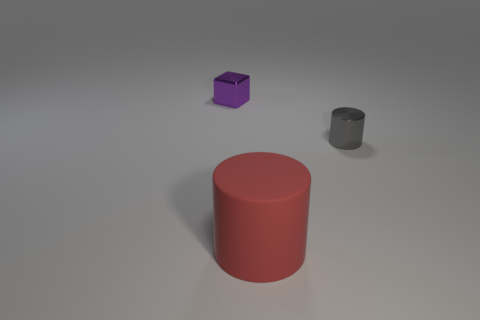Is there any other thing that has the same material as the red object?
Offer a very short reply. No. What number of things have the same material as the tiny gray cylinder?
Provide a succinct answer. 1. Is the number of tiny purple rubber objects less than the number of tiny gray metal things?
Provide a short and direct response. Yes. Do the small object that is on the left side of the small metal cylinder and the red object have the same material?
Your answer should be compact. No. How many cubes are tiny gray objects or big red rubber things?
Provide a succinct answer. 0. The object that is both on the left side of the tiny gray thing and on the right side of the small purple shiny cube has what shape?
Provide a succinct answer. Cylinder. The small object that is on the right side of the tiny metallic thing on the left side of the cylinder behind the rubber cylinder is what color?
Your response must be concise. Gray. Is the number of tiny shiny things that are in front of the purple shiny block less than the number of metallic objects?
Your answer should be compact. Yes. Does the tiny thing that is behind the small gray cylinder have the same shape as the tiny metallic thing that is right of the red matte cylinder?
Offer a terse response. No. What number of objects are things that are on the right side of the purple block or metal things?
Your response must be concise. 3. 